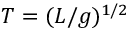<formula> <loc_0><loc_0><loc_500><loc_500>T = ( L / g ) ^ { 1 / 2 }</formula> 